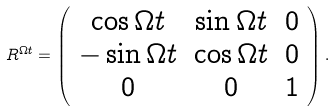Convert formula to latex. <formula><loc_0><loc_0><loc_500><loc_500>R ^ { \Omega t } = \left ( \begin{array} { c c c } \cos { \Omega t } & \sin { \Omega t } & 0 \\ - \sin { \Omega t } & \cos { \Omega t } & 0 \\ 0 & 0 & 1 \end{array} \right ) .</formula> 